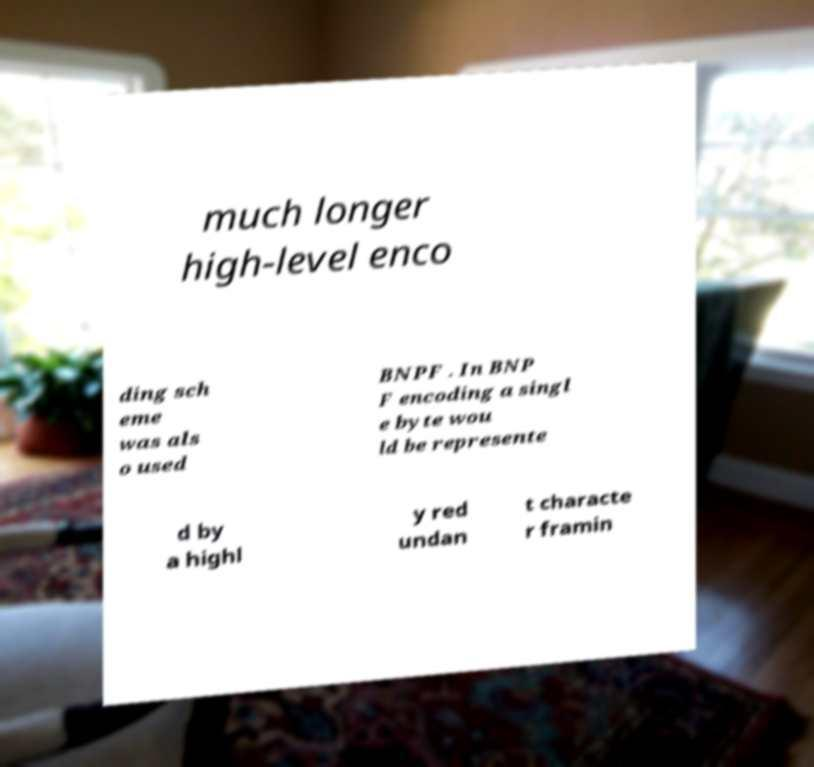What messages or text are displayed in this image? I need them in a readable, typed format. much longer high-level enco ding sch eme was als o used BNPF . In BNP F encoding a singl e byte wou ld be represente d by a highl y red undan t characte r framin 